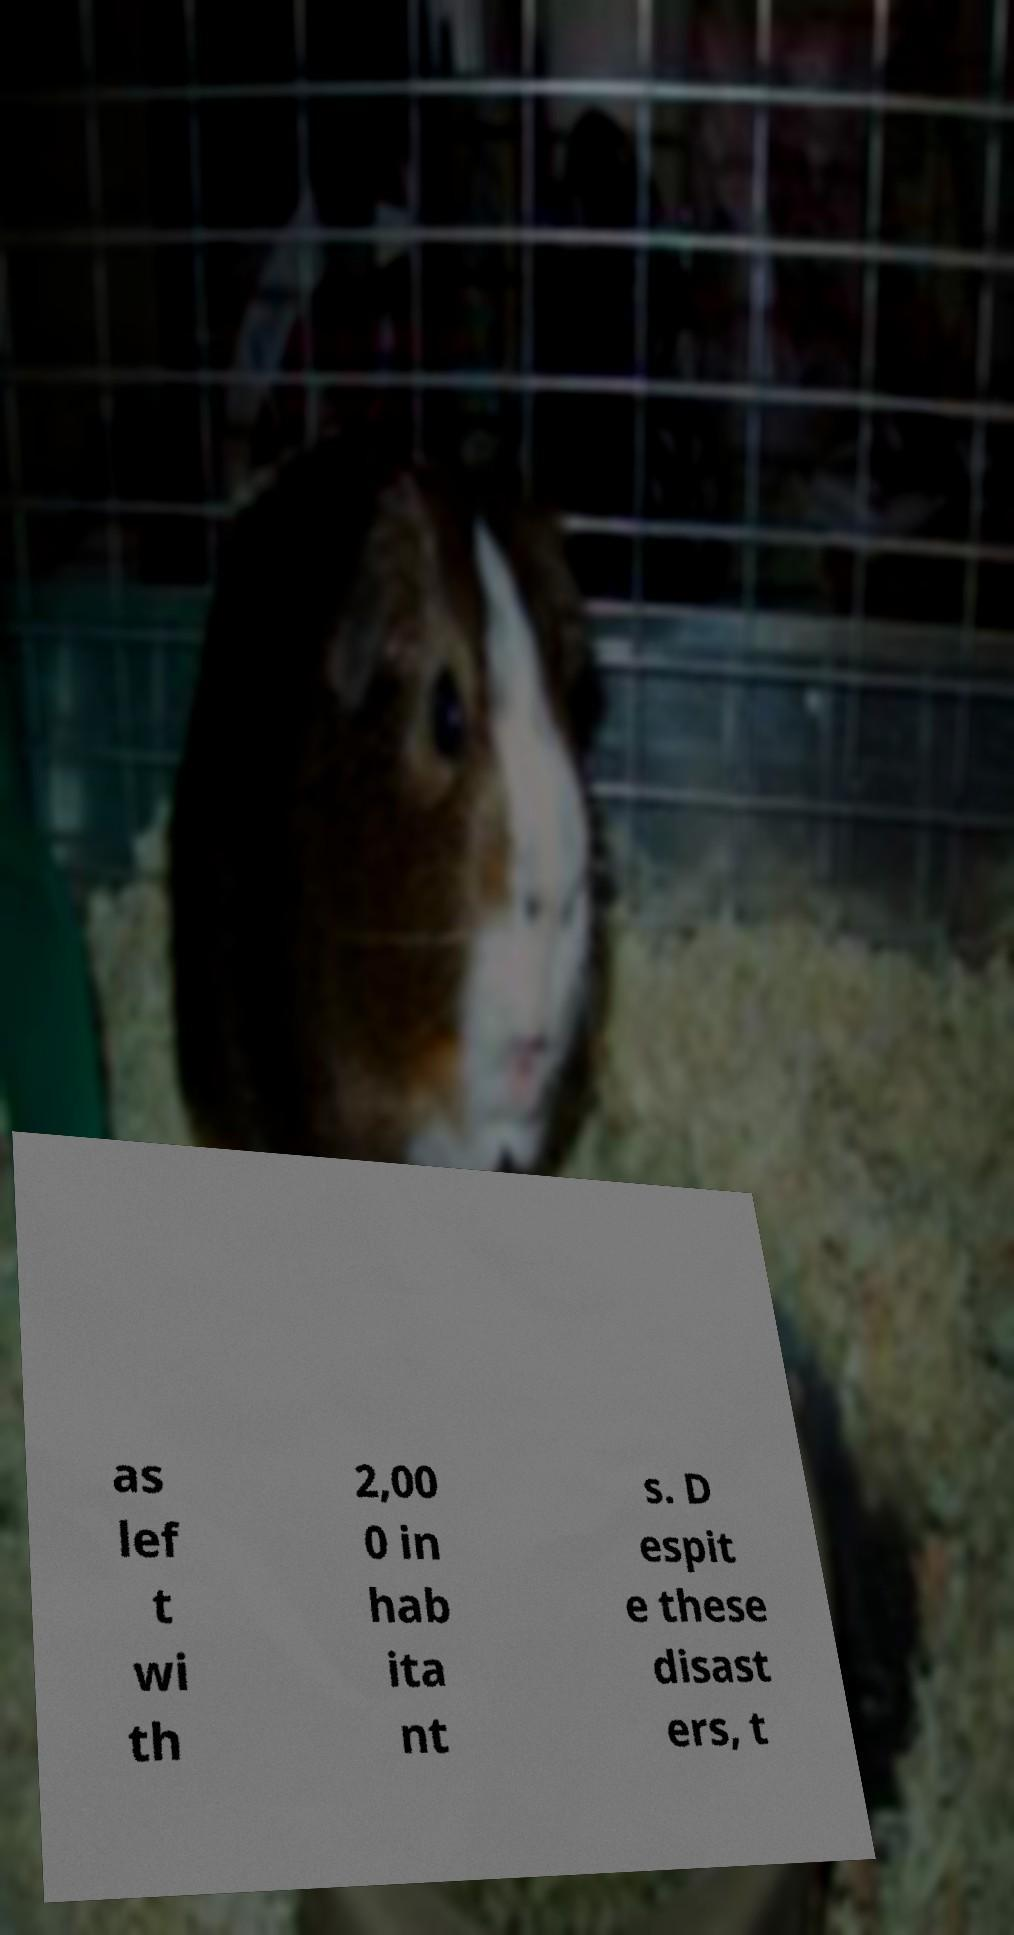Can you accurately transcribe the text from the provided image for me? as lef t wi th 2,00 0 in hab ita nt s. D espit e these disast ers, t 